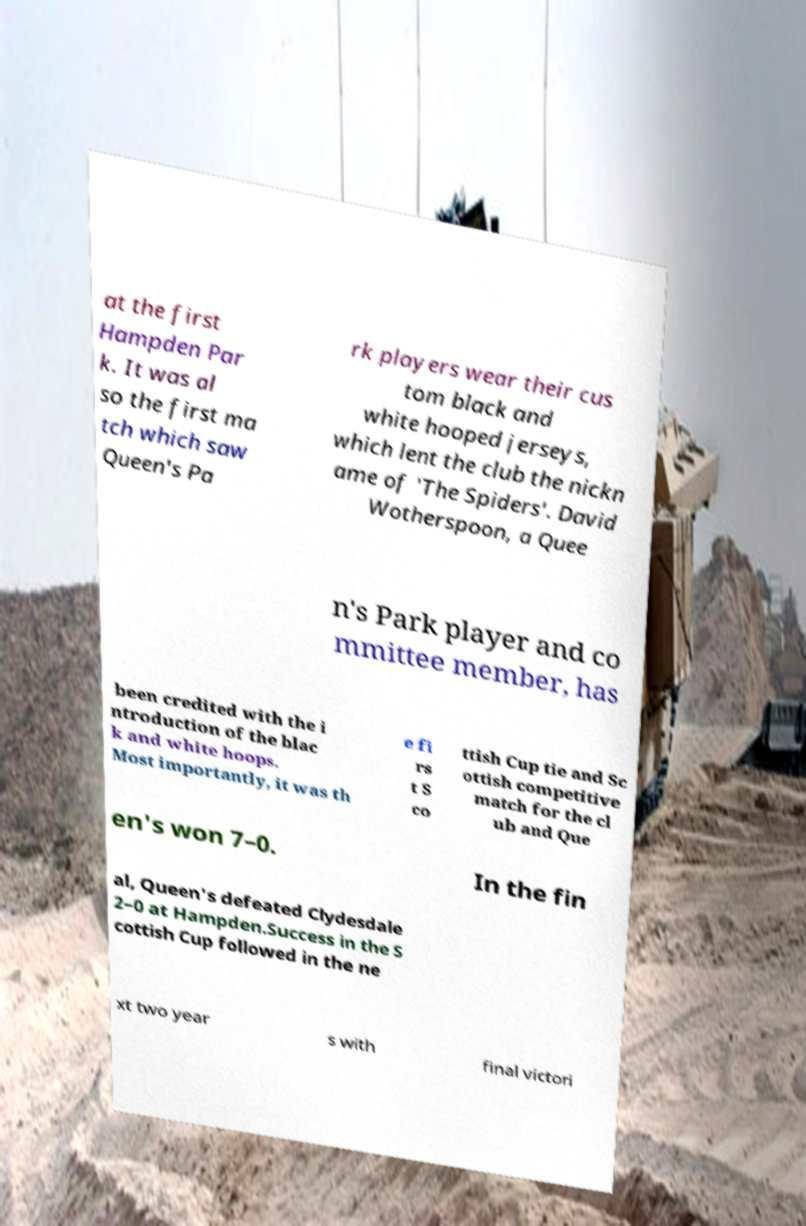For documentation purposes, I need the text within this image transcribed. Could you provide that? at the first Hampden Par k. It was al so the first ma tch which saw Queen's Pa rk players wear their cus tom black and white hooped jerseys, which lent the club the nickn ame of 'The Spiders'. David Wotherspoon, a Quee n's Park player and co mmittee member, has been credited with the i ntroduction of the blac k and white hoops. Most importantly, it was th e fi rs t S co ttish Cup tie and Sc ottish competitive match for the cl ub and Que en's won 7–0. In the fin al, Queen's defeated Clydesdale 2–0 at Hampden.Success in the S cottish Cup followed in the ne xt two year s with final victori 